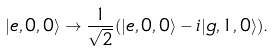<formula> <loc_0><loc_0><loc_500><loc_500>| e , 0 , 0 \rangle \rightarrow \frac { 1 } { \sqrt { 2 } } ( | e , 0 , 0 \rangle - i | g , 1 , 0 \rangle ) .</formula> 